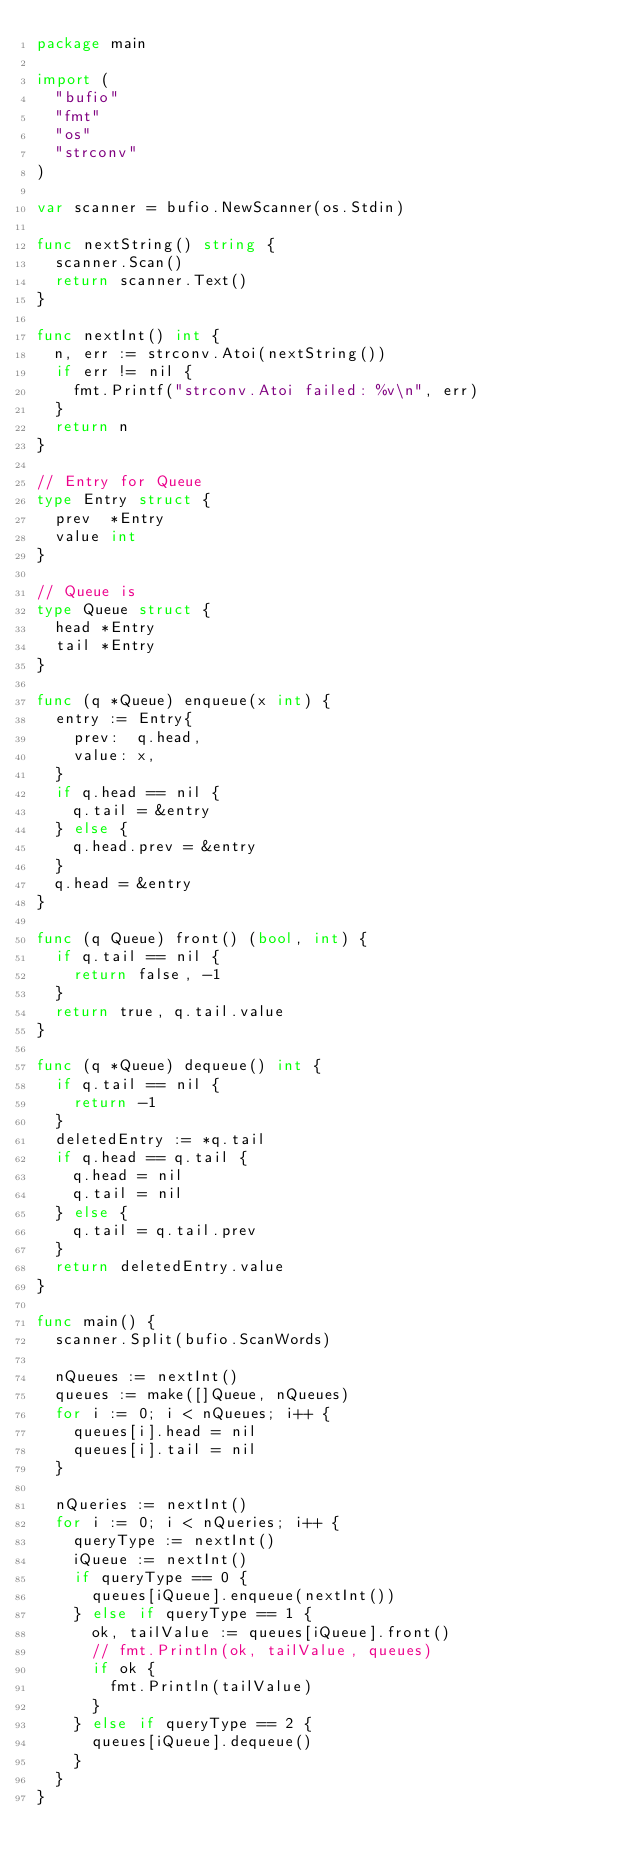Convert code to text. <code><loc_0><loc_0><loc_500><loc_500><_Go_>package main

import (
	"bufio"
	"fmt"
	"os"
	"strconv"
)

var scanner = bufio.NewScanner(os.Stdin)

func nextString() string {
	scanner.Scan()
	return scanner.Text()
}

func nextInt() int {
	n, err := strconv.Atoi(nextString())
	if err != nil {
		fmt.Printf("strconv.Atoi failed: %v\n", err)
	}
	return n
}

// Entry for Queue
type Entry struct {
	prev  *Entry
	value int
}

// Queue is
type Queue struct {
	head *Entry
	tail *Entry
}

func (q *Queue) enqueue(x int) {
	entry := Entry{
		prev:  q.head,
		value: x,
	}
	if q.head == nil {
		q.tail = &entry
	} else {
		q.head.prev = &entry
	}
	q.head = &entry
}

func (q Queue) front() (bool, int) {
	if q.tail == nil {
		return false, -1
	}
	return true, q.tail.value
}

func (q *Queue) dequeue() int {
	if q.tail == nil {
		return -1
	}
	deletedEntry := *q.tail
	if q.head == q.tail {
		q.head = nil
		q.tail = nil
	} else {
		q.tail = q.tail.prev
	}
	return deletedEntry.value
}

func main() {
	scanner.Split(bufio.ScanWords)

	nQueues := nextInt()
	queues := make([]Queue, nQueues)
	for i := 0; i < nQueues; i++ {
		queues[i].head = nil
		queues[i].tail = nil
	}

	nQueries := nextInt()
	for i := 0; i < nQueries; i++ {
		queryType := nextInt()
		iQueue := nextInt()
		if queryType == 0 {
			queues[iQueue].enqueue(nextInt())
		} else if queryType == 1 {
			ok, tailValue := queues[iQueue].front()
			// fmt.Println(ok, tailValue, queues)
			if ok {
				fmt.Println(tailValue)
			}
		} else if queryType == 2 {
			queues[iQueue].dequeue()
		}
	}
}

</code> 